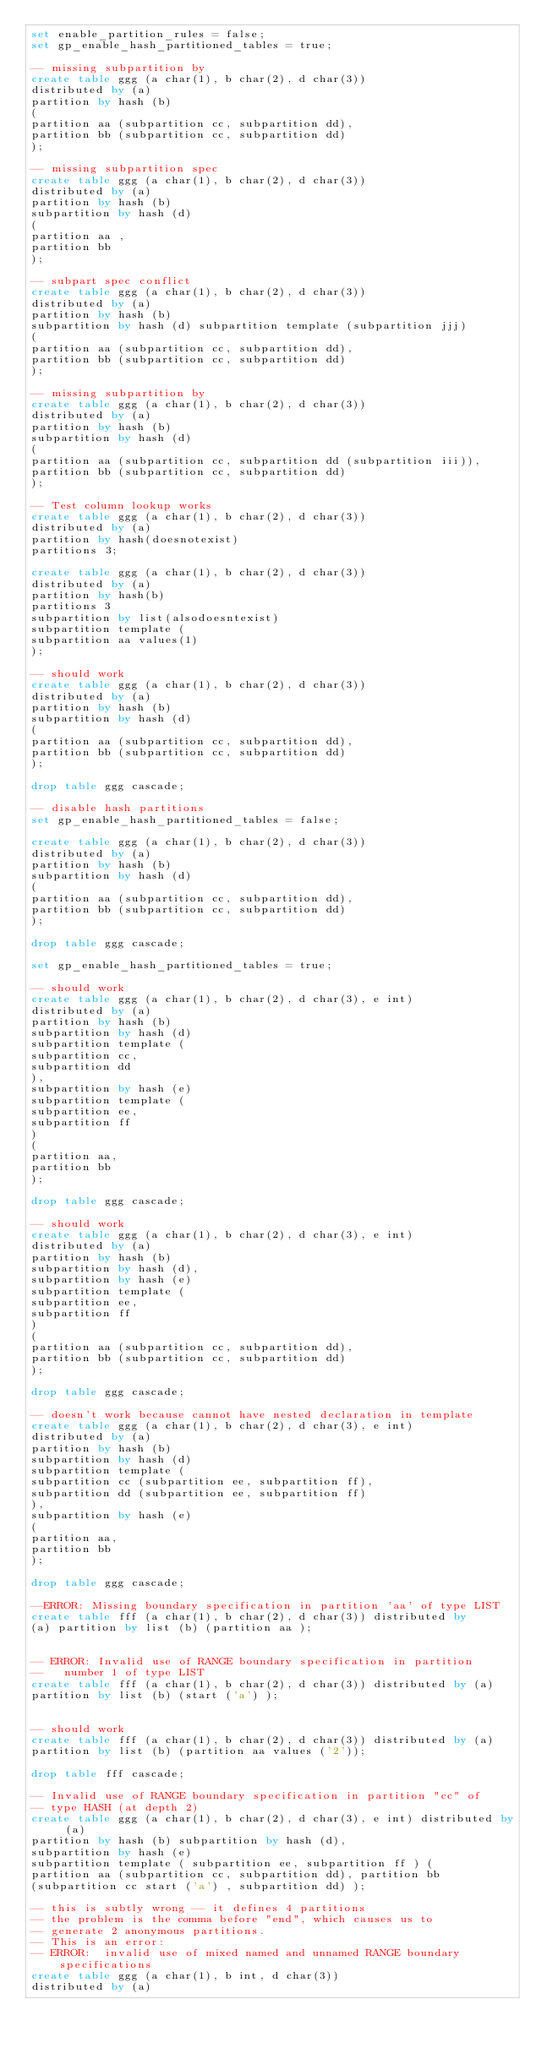Convert code to text. <code><loc_0><loc_0><loc_500><loc_500><_SQL_>set enable_partition_rules = false;
set gp_enable_hash_partitioned_tables = true;

-- missing subpartition by
create table ggg (a char(1), b char(2), d char(3))
distributed by (a)
partition by hash (b)
(
partition aa (subpartition cc, subpartition dd),
partition bb (subpartition cc, subpartition dd)
);

-- missing subpartition spec
create table ggg (a char(1), b char(2), d char(3))
distributed by (a)
partition by hash (b)
subpartition by hash (d) 
(
partition aa ,
partition bb 
);

-- subpart spec conflict
create table ggg (a char(1), b char(2), d char(3))
distributed by (a)
partition by hash (b) 
subpartition by hash (d) subpartition template (subpartition jjj)
(
partition aa (subpartition cc, subpartition dd),
partition bb (subpartition cc, subpartition dd)
);

-- missing subpartition by
create table ggg (a char(1), b char(2), d char(3))
distributed by (a)
partition by hash (b)
subpartition by hash (d)
(
partition aa (subpartition cc, subpartition dd (subpartition iii)),
partition bb (subpartition cc, subpartition dd)
);

-- Test column lookup works
create table ggg (a char(1), b char(2), d char(3))
distributed by (a)
partition by hash(doesnotexist)
partitions 3;

create table ggg (a char(1), b char(2), d char(3))
distributed by (a)
partition by hash(b)
partitions 3
subpartition by list(alsodoesntexist)
subpartition template (
subpartition aa values(1)
);

-- should work
create table ggg (a char(1), b char(2), d char(3))
distributed by (a)
partition by hash (b)
subpartition by hash (d) 
(
partition aa (subpartition cc, subpartition dd),
partition bb (subpartition cc, subpartition dd)
);

drop table ggg cascade;

-- disable hash partitions
set gp_enable_hash_partitioned_tables = false;

create table ggg (a char(1), b char(2), d char(3))
distributed by (a)
partition by hash (b)
subpartition by hash (d) 
(
partition aa (subpartition cc, subpartition dd),
partition bb (subpartition cc, subpartition dd)
);

drop table ggg cascade;

set gp_enable_hash_partitioned_tables = true;

-- should work
create table ggg (a char(1), b char(2), d char(3), e int)
distributed by (a)
partition by hash (b)
subpartition by hash (d) 
subpartition template ( 
subpartition cc,
subpartition dd
), 
subpartition by hash (e) 
subpartition template ( 
subpartition ee,
subpartition ff
) 
(
partition aa,
partition bb
);

drop table ggg cascade;

-- should work
create table ggg (a char(1), b char(2), d char(3), e int)
distributed by (a)
partition by hash (b)
subpartition by hash (d),
subpartition by hash (e)
subpartition template ( 
subpartition ee,
subpartition ff
) 
(
partition aa (subpartition cc, subpartition dd),
partition bb (subpartition cc, subpartition dd)
);

drop table ggg cascade;

-- doesn't work because cannot have nested declaration in template
create table ggg (a char(1), b char(2), d char(3), e int)
distributed by (a)
partition by hash (b)
subpartition by hash (d) 
subpartition template ( 
subpartition cc (subpartition ee, subpartition ff),
subpartition dd (subpartition ee, subpartition ff)
), 
subpartition by hash (e) 
(
partition aa,
partition bb
);

drop table ggg cascade;

--ERROR: Missing boundary specification in partition 'aa' of type LIST 
create table fff (a char(1), b char(2), d char(3)) distributed by
(a) partition by list (b) (partition aa ); 


-- ERROR: Invalid use of RANGE boundary specification in partition
--   number 1 of type LIST
create table fff (a char(1), b char(2), d char(3)) distributed by (a)
partition by list (b) (start ('a') );


-- should work
create table fff (a char(1), b char(2), d char(3)) distributed by (a)
partition by list (b) (partition aa values ('2'));

drop table fff cascade;

-- Invalid use of RANGE boundary specification in partition "cc" of 
-- type HASH (at depth 2)
create table ggg (a char(1), b char(2), d char(3), e int) distributed by (a)
partition by hash (b) subpartition by hash (d),
subpartition by hash (e) 
subpartition template ( subpartition ee, subpartition ff ) (
partition aa (subpartition cc, subpartition dd), partition bb
(subpartition cc start ('a') , subpartition dd) );

-- this is subtly wrong -- it defines 4 partitions
-- the problem is the comma before "end", which causes us to
-- generate 2 anonymous partitions.
-- This is an error: 
-- ERROR:  invalid use of mixed named and unnamed RANGE boundary specifications
create table ggg (a char(1), b int, d char(3))
distributed by (a)</code> 